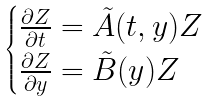Convert formula to latex. <formula><loc_0><loc_0><loc_500><loc_500>\begin{cases} \frac { \partial Z } { \partial t } = \tilde { A } ( t , y ) Z \\ \frac { \partial Z } { \partial y } = \tilde { B } ( y ) Z \end{cases}</formula> 